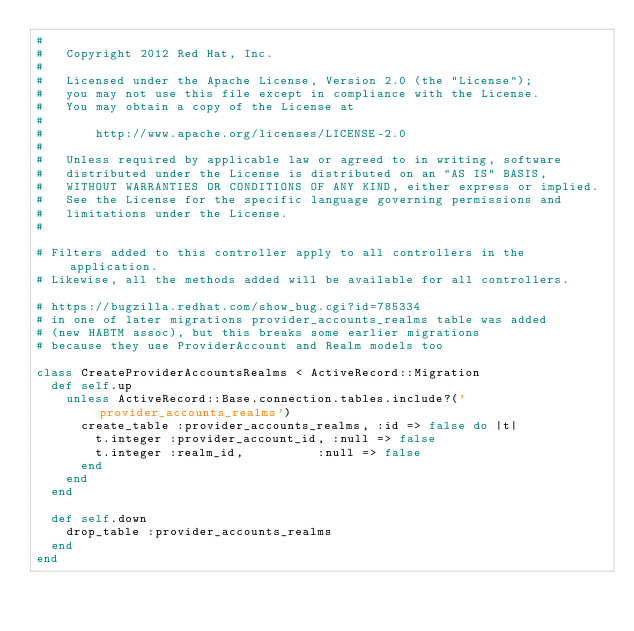<code> <loc_0><loc_0><loc_500><loc_500><_Ruby_>#
#   Copyright 2012 Red Hat, Inc.
#
#   Licensed under the Apache License, Version 2.0 (the "License");
#   you may not use this file except in compliance with the License.
#   You may obtain a copy of the License at
#
#       http://www.apache.org/licenses/LICENSE-2.0
#
#   Unless required by applicable law or agreed to in writing, software
#   distributed under the License is distributed on an "AS IS" BASIS,
#   WITHOUT WARRANTIES OR CONDITIONS OF ANY KIND, either express or implied.
#   See the License for the specific language governing permissions and
#   limitations under the License.
#

# Filters added to this controller apply to all controllers in the application.
# Likewise, all the methods added will be available for all controllers.

# https://bugzilla.redhat.com/show_bug.cgi?id=785334
# in one of later migrations provider_accounts_realms table was added
# (new HABTM assoc), but this breaks some earlier migrations
# because they use ProviderAccount and Realm models too

class CreateProviderAccountsRealms < ActiveRecord::Migration
  def self.up
    unless ActiveRecord::Base.connection.tables.include?('provider_accounts_realms')
      create_table :provider_accounts_realms, :id => false do |t|
        t.integer :provider_account_id, :null => false
        t.integer :realm_id,          :null => false
      end
    end
  end

  def self.down
    drop_table :provider_accounts_realms
  end
end
</code> 